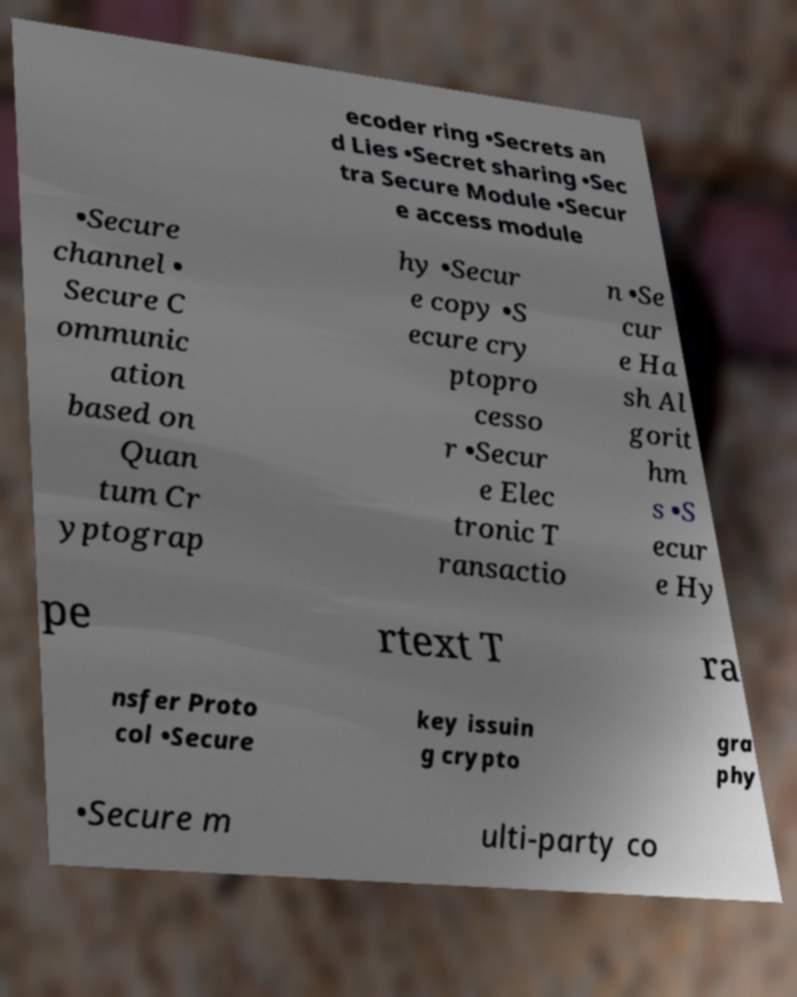Can you accurately transcribe the text from the provided image for me? ecoder ring •Secrets an d Lies •Secret sharing •Sec tra Secure Module •Secur e access module •Secure channel • Secure C ommunic ation based on Quan tum Cr yptograp hy •Secur e copy •S ecure cry ptopro cesso r •Secur e Elec tronic T ransactio n •Se cur e Ha sh Al gorit hm s •S ecur e Hy pe rtext T ra nsfer Proto col •Secure key issuin g crypto gra phy •Secure m ulti-party co 